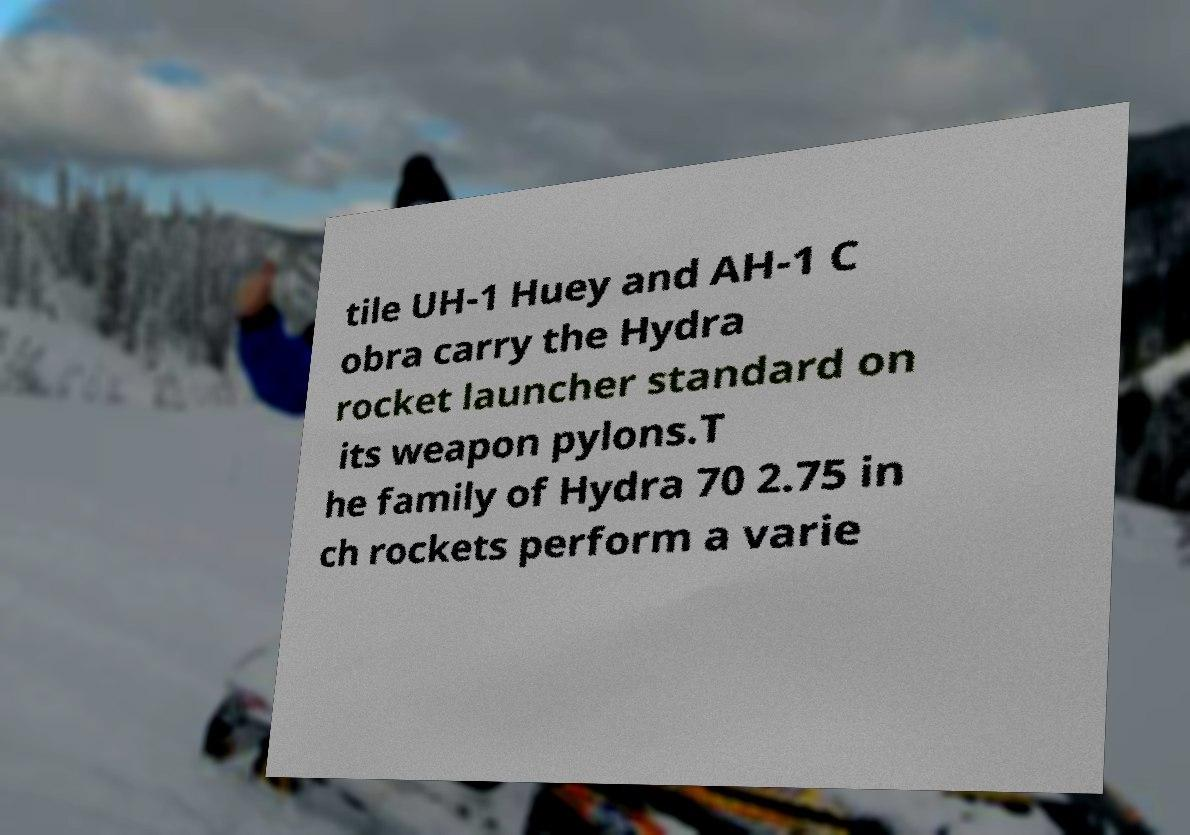For documentation purposes, I need the text within this image transcribed. Could you provide that? tile UH-1 Huey and AH-1 C obra carry the Hydra rocket launcher standard on its weapon pylons.T he family of Hydra 70 2.75 in ch rockets perform a varie 